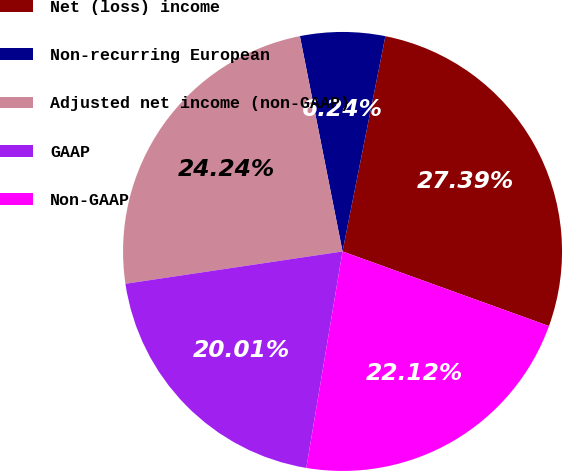Convert chart to OTSL. <chart><loc_0><loc_0><loc_500><loc_500><pie_chart><fcel>Net (loss) income<fcel>Non-recurring European<fcel>Adjusted net income (non-GAAP)<fcel>GAAP<fcel>Non-GAAP<nl><fcel>27.39%<fcel>6.24%<fcel>24.24%<fcel>20.01%<fcel>22.12%<nl></chart> 